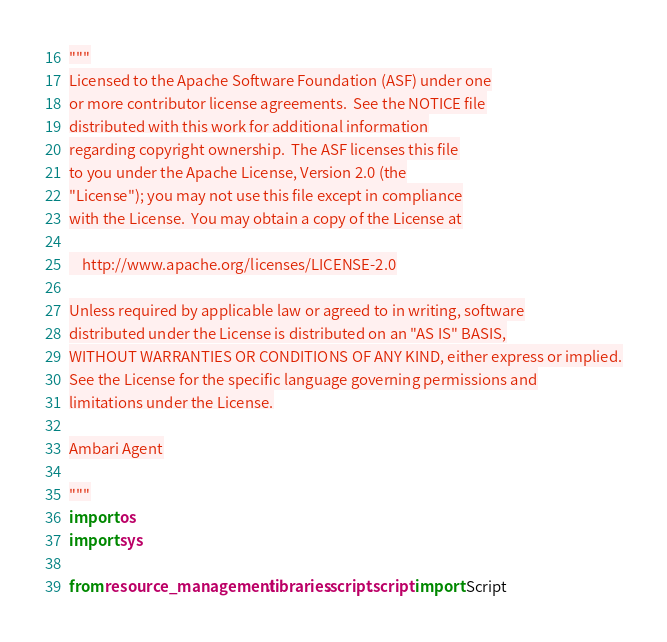<code> <loc_0><loc_0><loc_500><loc_500><_Python_>"""
Licensed to the Apache Software Foundation (ASF) under one
or more contributor license agreements.  See the NOTICE file
distributed with this work for additional information
regarding copyright ownership.  The ASF licenses this file
to you under the Apache License, Version 2.0 (the
"License"); you may not use this file except in compliance
with the License.  You may obtain a copy of the License at

    http://www.apache.org/licenses/LICENSE-2.0

Unless required by applicable law or agreed to in writing, software
distributed under the License is distributed on an "AS IS" BASIS,
WITHOUT WARRANTIES OR CONDITIONS OF ANY KIND, either express or implied.
See the License for the specific language governing permissions and
limitations under the License.

Ambari Agent

"""
import os
import sys

from resource_management.libraries.script.script import Script</code> 